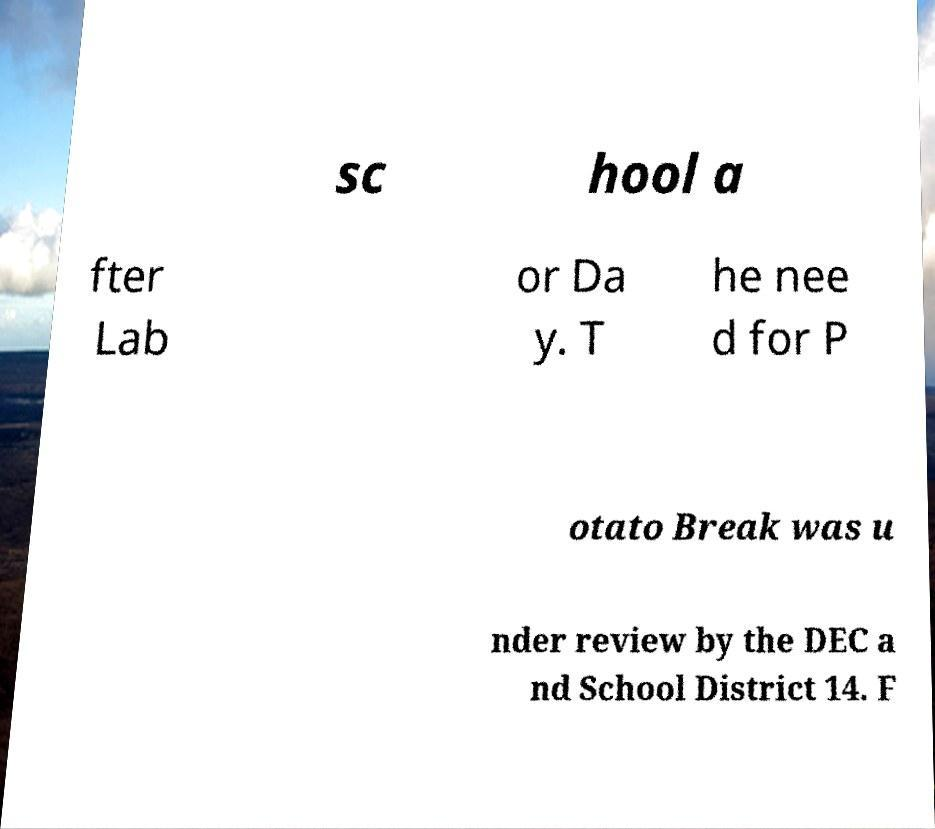I need the written content from this picture converted into text. Can you do that? sc hool a fter Lab or Da y. T he nee d for P otato Break was u nder review by the DEC a nd School District 14. F 